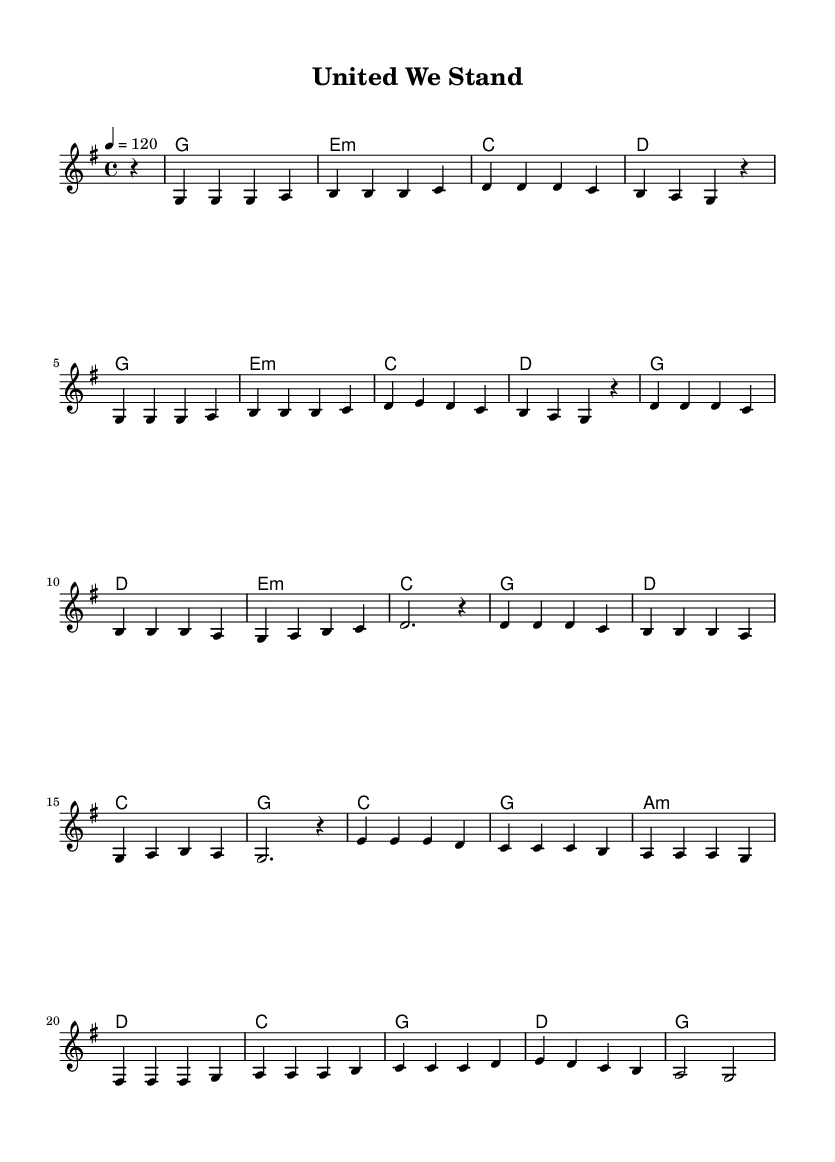What is the key signature of this music? The key signature is G major, which contains one sharp (F#) as indicated at the beginning of the sheet music.
Answer: G major What is the time signature of this piece? The time signature is 4/4, meaning there are four beats in each measure and a quarter note receives one beat, as stated at the beginning of the sheet music.
Answer: 4/4 What is the tempo marking of this composition? The tempo marking is 120 beats per minute, as specified in the score which sets the pace for the piece.
Answer: 120 How many measures are present in the verse section? The verse section consists of two full cycles of eight measures each, resulting in a total of sixteen measures.
Answer: 16 What type of chord is used in the chorus? The chorus features a mix of major and minor chords, specifically G major, D major, E minor, and C major, reflecting typical pop harmonies.
Answer: Major and minor chords What is the primary thematic element expressed through the lyrics indicated in the score? While the lyrics are not provided, typically pop songs celebrate themes of unity and diversity, which aligns with the title "United We Stand." This can be inferred from the context and title.
Answer: Unity and diversity What is the last chord in the bridge section? The last chord in the bridge section is G major, as indicated in the harmonies at the conclusion of that section.
Answer: G major 